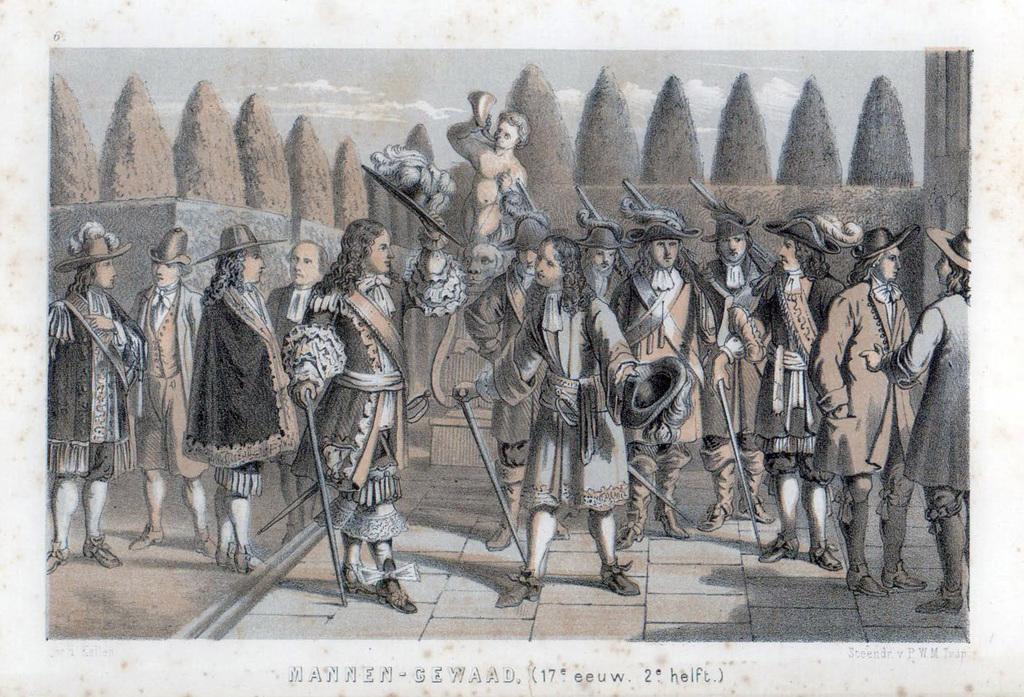Describe this image in one or two sentences. In this image we can see a poster. On this poster we can see pictures of persons and trees. In the background there is sky with clouds. At the bottom of the image we can see something is written on it. 